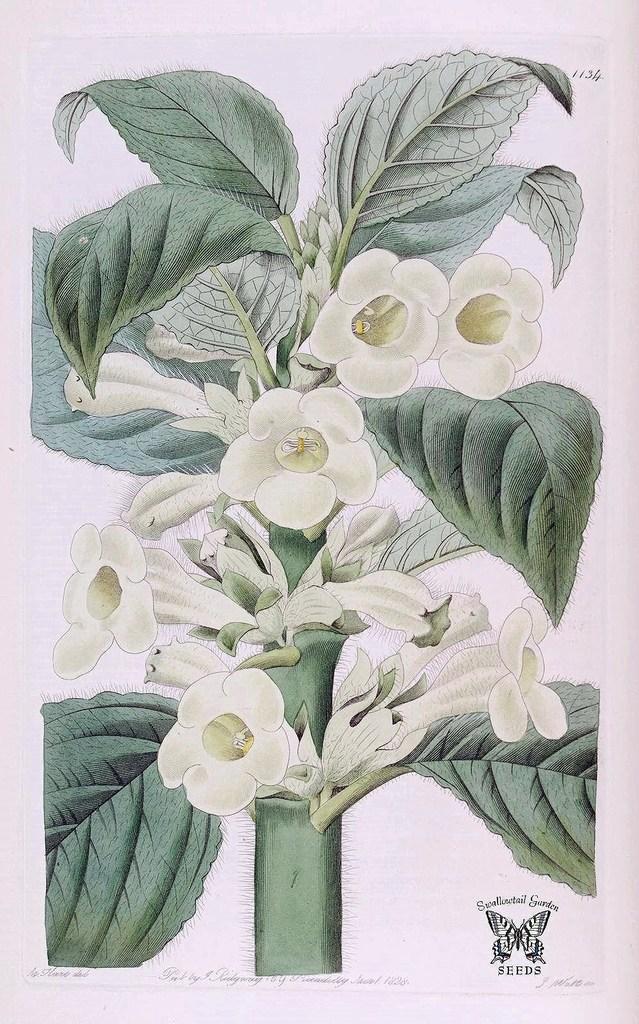Can you describe this image briefly? This is a painting, in this image in the center there is a plant and some flowers. 